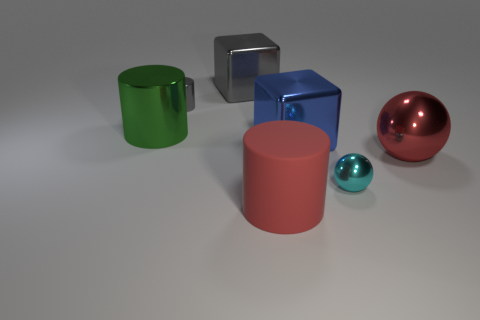Add 3 green metallic balls. How many objects exist? 10 Subtract all big green cylinders. How many cylinders are left? 2 Subtract all spheres. How many objects are left? 5 Subtract all gray cubes. How many cubes are left? 1 Subtract 0 cyan cylinders. How many objects are left? 7 Subtract 2 blocks. How many blocks are left? 0 Subtract all blue blocks. Subtract all gray spheres. How many blocks are left? 1 Subtract all purple cylinders. How many brown cubes are left? 0 Subtract all balls. Subtract all small shiny spheres. How many objects are left? 4 Add 6 blocks. How many blocks are left? 8 